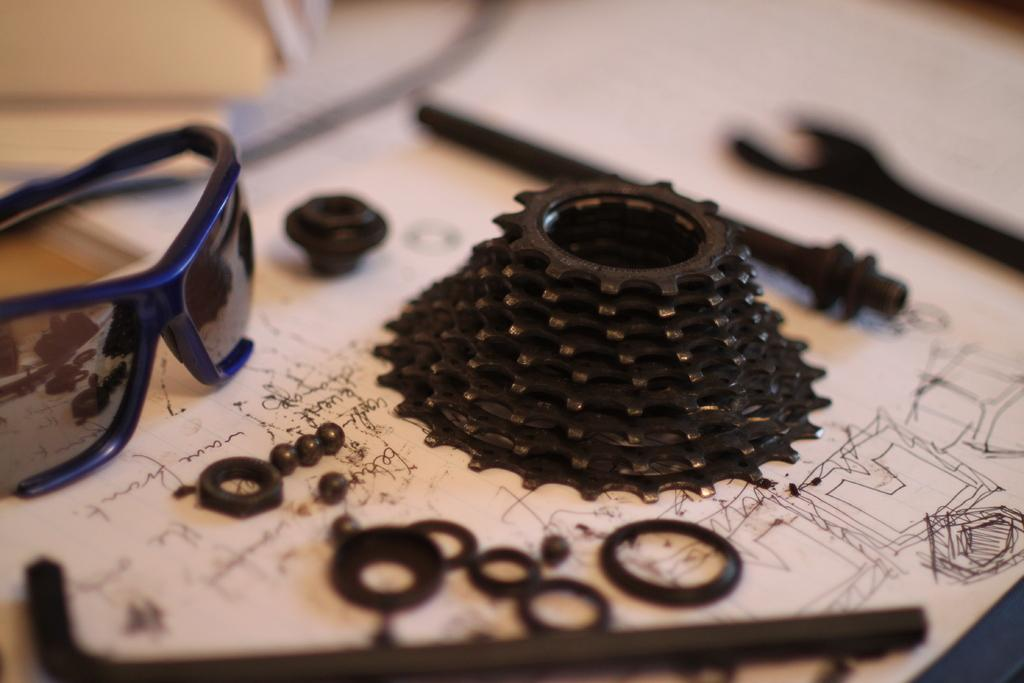What is in the center of the image? There is a table in the center of the image. What is placed on the table? There is a paper and glasses on the table. What else can be seen on the table? There are tools on the table. What type of blade can be seen in the image? There is no blade present in the image. Is the table surrounded by a thick fog in the image? There is no fog present in the image. 